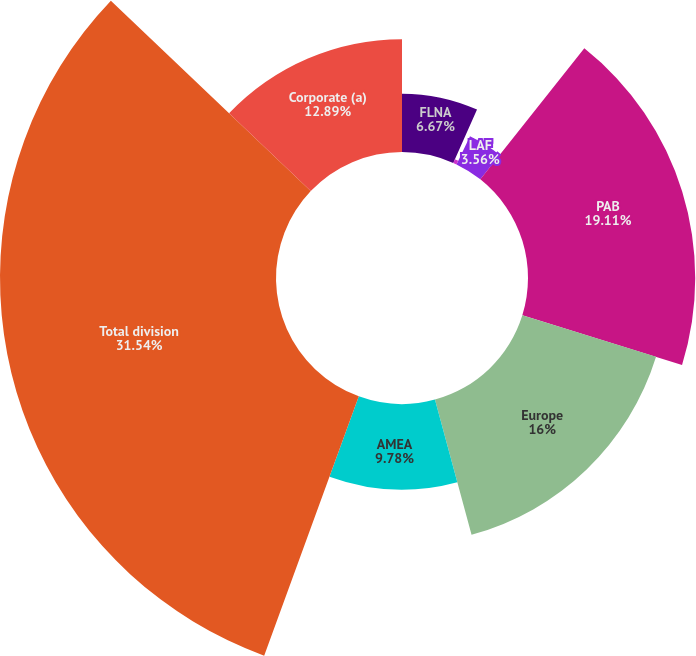Convert chart. <chart><loc_0><loc_0><loc_500><loc_500><pie_chart><fcel>FLNA<fcel>QFNA<fcel>LAF<fcel>PAB<fcel>Europe<fcel>AMEA<fcel>Total division<fcel>Corporate (a)<nl><fcel>6.67%<fcel>0.45%<fcel>3.56%<fcel>19.11%<fcel>16.0%<fcel>9.78%<fcel>31.54%<fcel>12.89%<nl></chart> 